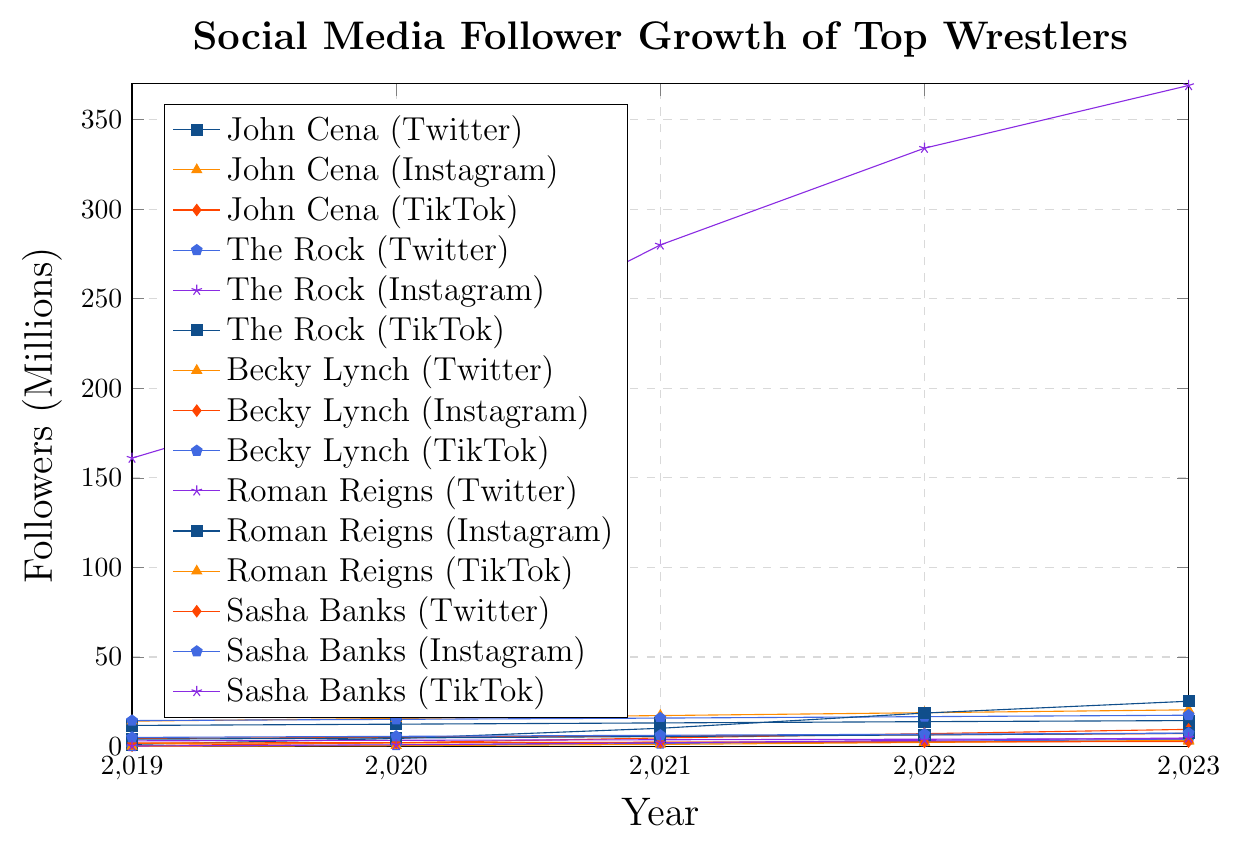What's the platform with the highest follower count for The Rock in 2023? The platform with the highest follower count can be identified by looking at the y-axis values corresponding to The Rock's lines. Among Twitter, Instagram, and TikTok, The Rock's Instagram account has the highest follower count at 369 million.
Answer: Instagram Which wrestler has the highest increase in Twitter followers from 2019 to 2023? To determine the wrestler with the highest increase, subtract the 2019 follower count from the 2023 count for each wrestler's Twitter followers. The wrestler with the highest result has the largest increase. John Cena's increase, from 11.8 to 14.5, is 2.7 million; The Rock's increase is 3 million; Becky Lynch’s increase is 1.2 million; Roman Reigns' increase is 1.2 million; Sasha Banks' increase is 0.8 million. Therefore, The Rock has the highest increase by 3 million followers.
Answer: The Rock Compare the follower growth of John Cena on TikTok and Instagram from 2019 to 2023. Which platform grew more, and by how much? For TikTok: From 0.5 million to 9.6 million, the increase is 9.1 million. For Instagram: From 14.2 million to 20.5 million, the increase is 6.3 million. Therefore, TikTok grew more by 2.8 million followers.
Answer: TikTok grew more by 2.8 million What's the average number of Instagram followers of Becky Lynch from 2019 to 2023? Add the number of Instagram followers of Becky Lynch for each year from 2019 to 2023 and divide by the number of years. (4.5 + 5.2 + 5.9 + 6.6 + 7.3) / 5 = 5.9 million followers (average).
Answer: 5.9 million Which platform had the lowest follower count for Roman Reigns in 2022? Check the y-axis values for Roman Reigns’ lines for 2022. Twitter followers: 4.1 million, Instagram followers: 6.5 million, TikTok followers: 2.3 million. Thus, TikTok had the lowest follower count.
Answer: TikTok Which wrestler gained the most TikTok followers between 2020 and 2023? Subtract the number of TikTok followers in 2020 from the number in 2023 for each wrestler. The wrestler with the highest result gained the most. John Cena: 9.6 - 2.1 = 7.5 million, The Rock: 25.3 - 4.5 = 20.8 million, Becky Lynch: 4.1 - 0.8 = 3.3 million, Roman Reigns: 3.5 - 0.5 = 3 million, Sasha Banks: 4.8 - 1.0 = 3.8 million. Therefore, The Rock gained the most TikTok followers by 20.8 million.
Answer: The Rock Which wrestler had the smallest follower increase on any platform from 2019 to 2023? Calculate the increases for each wrestler on each platform over the years. The smallest increase is the minimum value obtained. Becky Lynch's TikTok followers increased from 0.2 to 4.1, a 3.9 million increase; her Twitter went from 1.8 to 3.0 (1.2 increase), and Instagram from 4.5 to 7.3 (2.8 increase). Roman Reigns' TikTok followers increased from 0.1 to 3.5 (3.4 increase); Twitter went from 3.2 to 4.4 (1.2 increase), and Instagram from 4.1 to 7.4 (3.3 increase). Sasha Banks' TikTok from 0.3 to 4.8 (4.5 increase); Twitter from 2.0 to 2.8 (0.8 increase), Instagram from 5.1 to 7.5 (2.4 increase). John Cena's TikTok from 0.5 to 9.6 (9.1 increase); Twitter from 11.8 to 14.5 (2.7 increase), Instagram from 14.2 to 20.5 (6.3 increase). The Rock's TikTok from 1.2 to 25.3 (24.1 increase); Twitter from 14.5 to 17.5 (3 million), and Instagram from 161.0 to 369.0 (208 increase). Therefore, Sasha Banks' Twitter followers had the smallest increase by 0.8 million followers.
Answer: Sasha Banks (Twitter) 